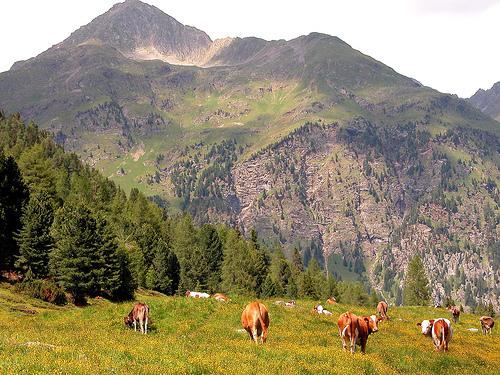How many species can be seen here of mammals? one 